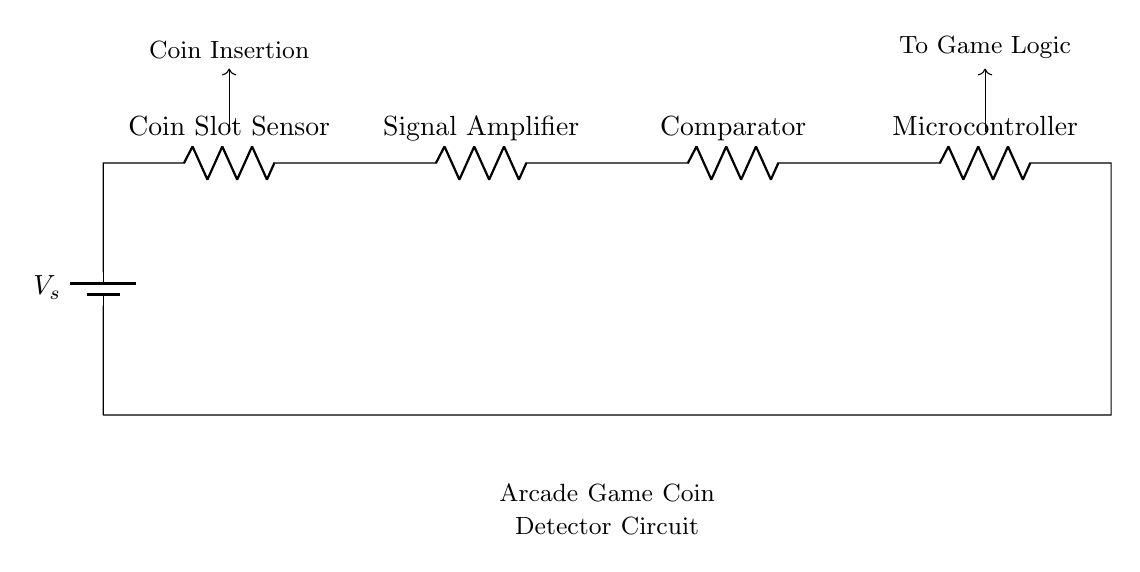What is the power source in this circuit? The power source is represented by the component labeled as V_s, which is a battery, indicating its role in providing the necessary voltage for the circuit to operate.
Answer: battery What are the components used in the circuit? The components in the circuit include a Coin Slot Sensor, Signal Amplifier, Comparator, and Microcontroller, as labeled in the diagram.
Answer: Coin Slot Sensor, Signal Amplifier, Comparator, Microcontroller What is the function of the Microcontroller in this circuit? The Microcontroller processes the signals received from the Comparator, leading to further actions like game logic operations after a coin is detected.
Answer: Processing signals How many resistors are present in the circuit? There are four resistors in the circuit, one for each component labeled as a resistor: Coin Slot Sensor, Signal Amplifier, Comparator, and Microcontroller.
Answer: four What does the arrowed connection from the Coin Slot Sensor indicate? The arrowed connection signifies the flow of the signal from the Coin Slot Sensor to the Signal Amplifier, indicating where the signal is directed after a coin insertion is detected.
Answer: Signal flow Which component directly follows the Coin Slot Sensor in the circuit layout? The component that directly follows the Coin Slot Sensor is the Signal Amplifier, as indicated by the arrangement in series.
Answer: Signal Amplifier What is the output connection from the Microcontroller for? The output connection from the Microcontroller is directed towards the game logic, indicating that it sends a processed signal to control gameplay based on the coin detection outcome.
Answer: To Game Logic 